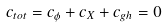Convert formula to latex. <formula><loc_0><loc_0><loc_500><loc_500>c _ { t o t } = c _ { \phi } + c _ { X } + c _ { g h } = 0</formula> 